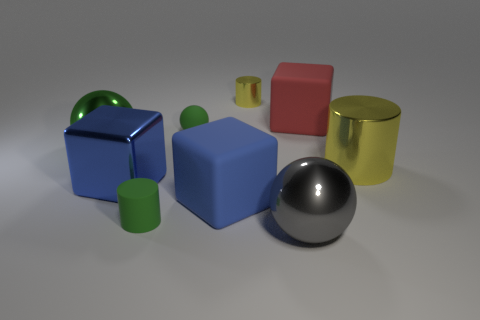Do the large red block that is behind the gray shiny thing and the tiny green cylinder have the same material?
Keep it short and to the point. Yes. There is a yellow cylinder that is the same size as the red cube; what is its material?
Provide a succinct answer. Metal. What number of other objects are the same material as the big green sphere?
Provide a succinct answer. 4. Do the green cylinder and the rubber block behind the large blue shiny block have the same size?
Offer a terse response. No. Are there fewer big red matte blocks in front of the gray sphere than gray metallic spheres that are left of the large shiny cube?
Offer a very short reply. No. What size is the rubber cylinder that is in front of the green rubber ball?
Provide a short and direct response. Small. Is the size of the rubber sphere the same as the red object?
Provide a succinct answer. No. How many yellow metal cylinders are both on the right side of the red object and to the left of the red thing?
Your answer should be very brief. 0. How many purple things are either rubber cylinders or rubber cubes?
Your answer should be very brief. 0. What number of rubber objects are large red things or big blue things?
Keep it short and to the point. 2. 